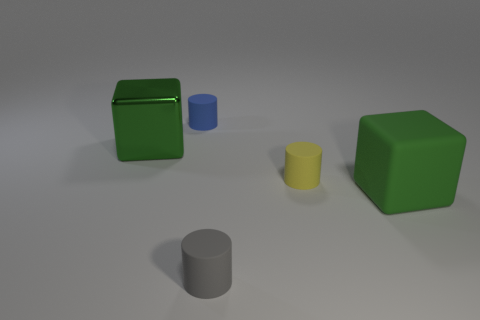Add 4 tiny yellow cylinders. How many objects exist? 9 Subtract all cubes. How many objects are left? 3 Add 5 large green metal balls. How many large green metal balls exist? 5 Subtract 0 purple cylinders. How many objects are left? 5 Subtract all tiny yellow matte cylinders. Subtract all yellow cylinders. How many objects are left? 3 Add 3 matte cylinders. How many matte cylinders are left? 6 